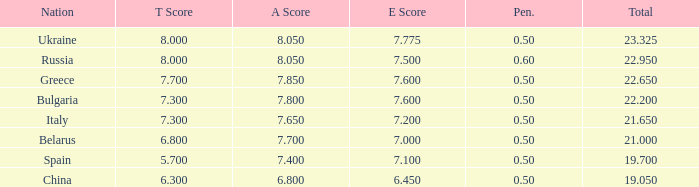1? None. 